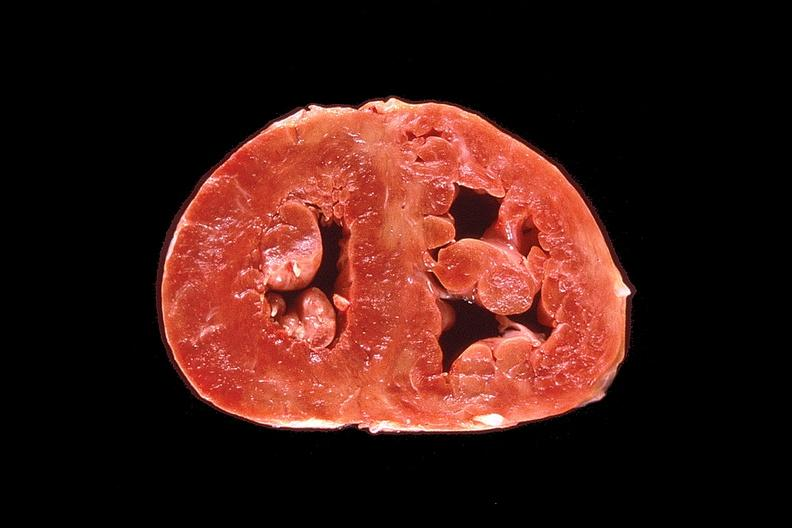why does this image show heart, marked right ventricular hypertrophy?
Answer the question using a single word or phrase. Due to pulmonary hypertension 